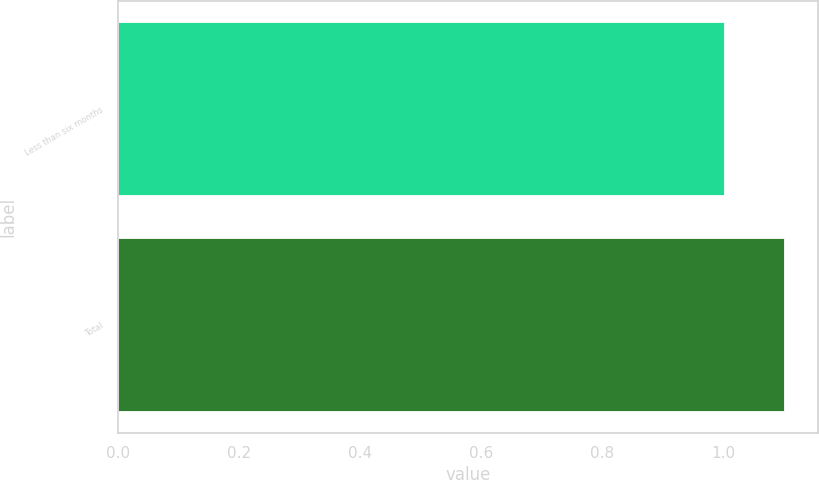Convert chart to OTSL. <chart><loc_0><loc_0><loc_500><loc_500><bar_chart><fcel>Less than six months<fcel>Total<nl><fcel>1<fcel>1.1<nl></chart> 